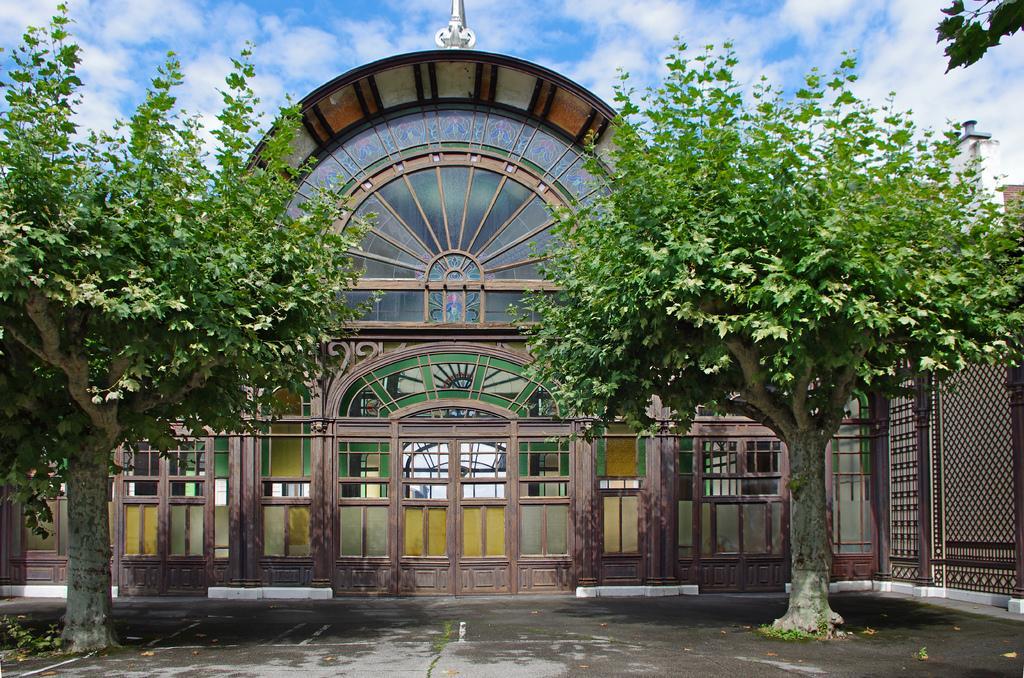Please provide a concise description of this image. In this picture we can see a building,trees and we can see sky in the background. 